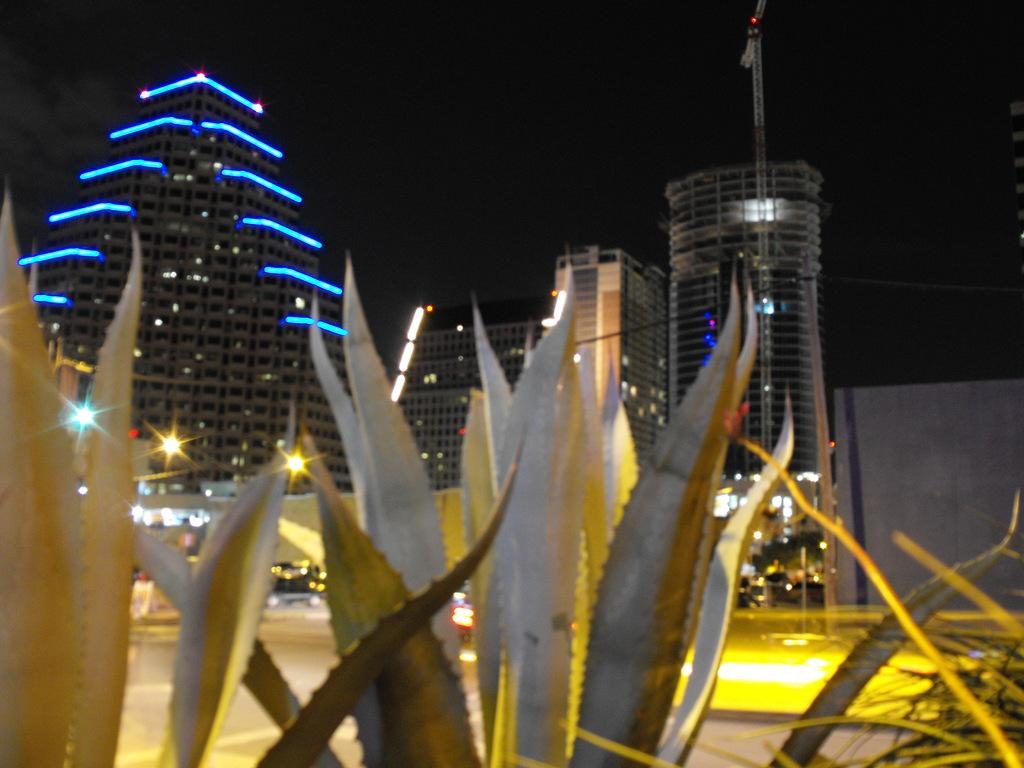What type of structures can be seen in the image? There are buildings in the image. What type of lighting is present in the image? Pole lights are present in the image. What type of vegetation is in the image? There are plants in the image. What type of lighting is present on the buildings? The buildings have lighting. What nation is at war in the image? There is no indication of a war or a specific nation in the image. 